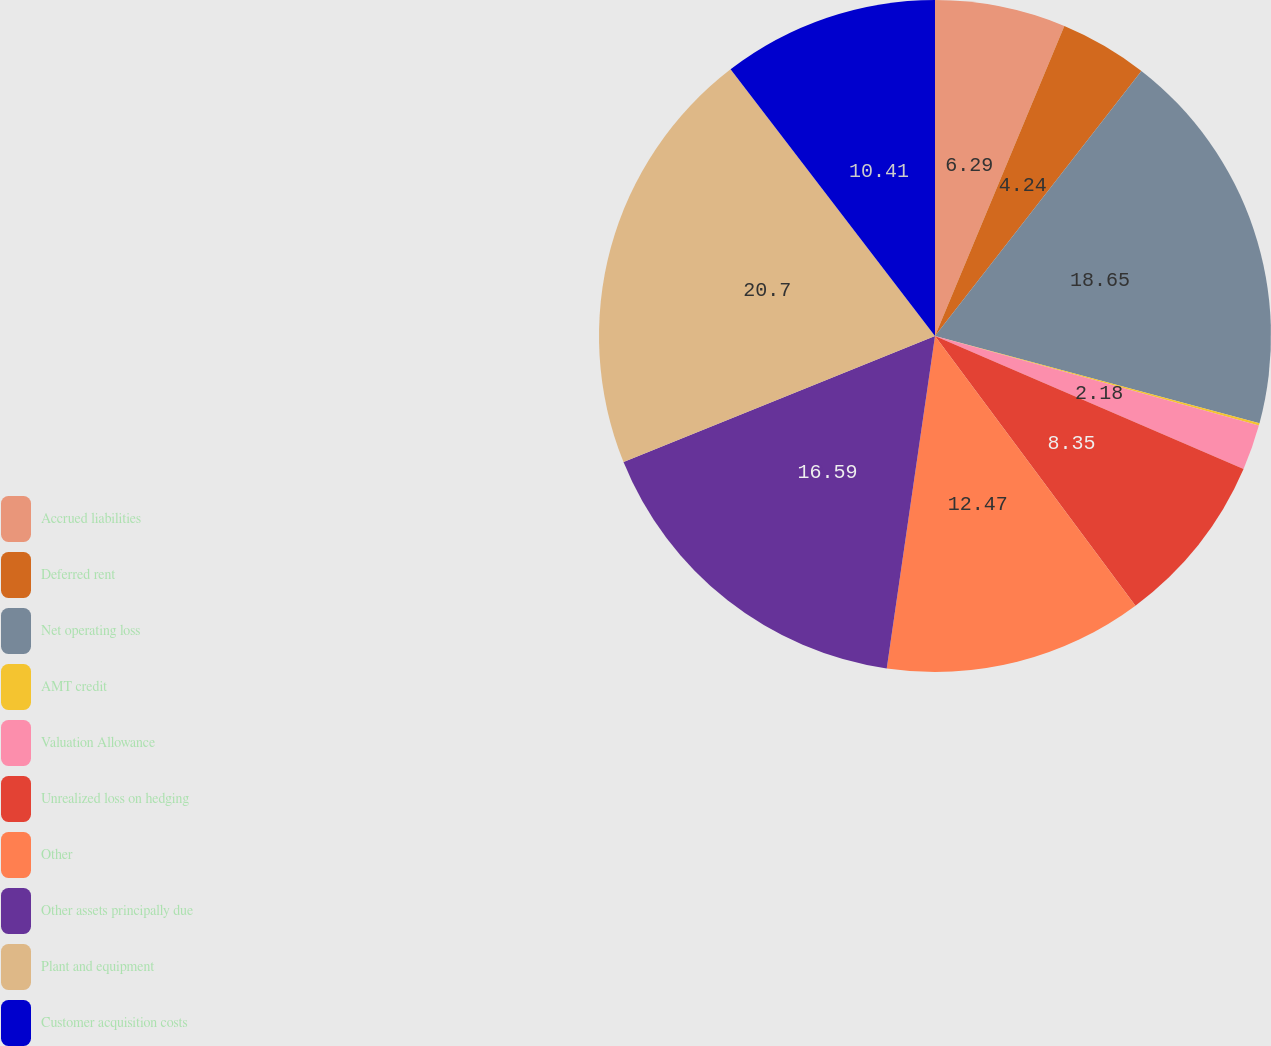Convert chart. <chart><loc_0><loc_0><loc_500><loc_500><pie_chart><fcel>Accrued liabilities<fcel>Deferred rent<fcel>Net operating loss<fcel>AMT credit<fcel>Valuation Allowance<fcel>Unrealized loss on hedging<fcel>Other<fcel>Other assets principally due<fcel>Plant and equipment<fcel>Customer acquisition costs<nl><fcel>6.29%<fcel>4.24%<fcel>18.65%<fcel>0.12%<fcel>2.18%<fcel>8.35%<fcel>12.47%<fcel>16.59%<fcel>20.71%<fcel>10.41%<nl></chart> 